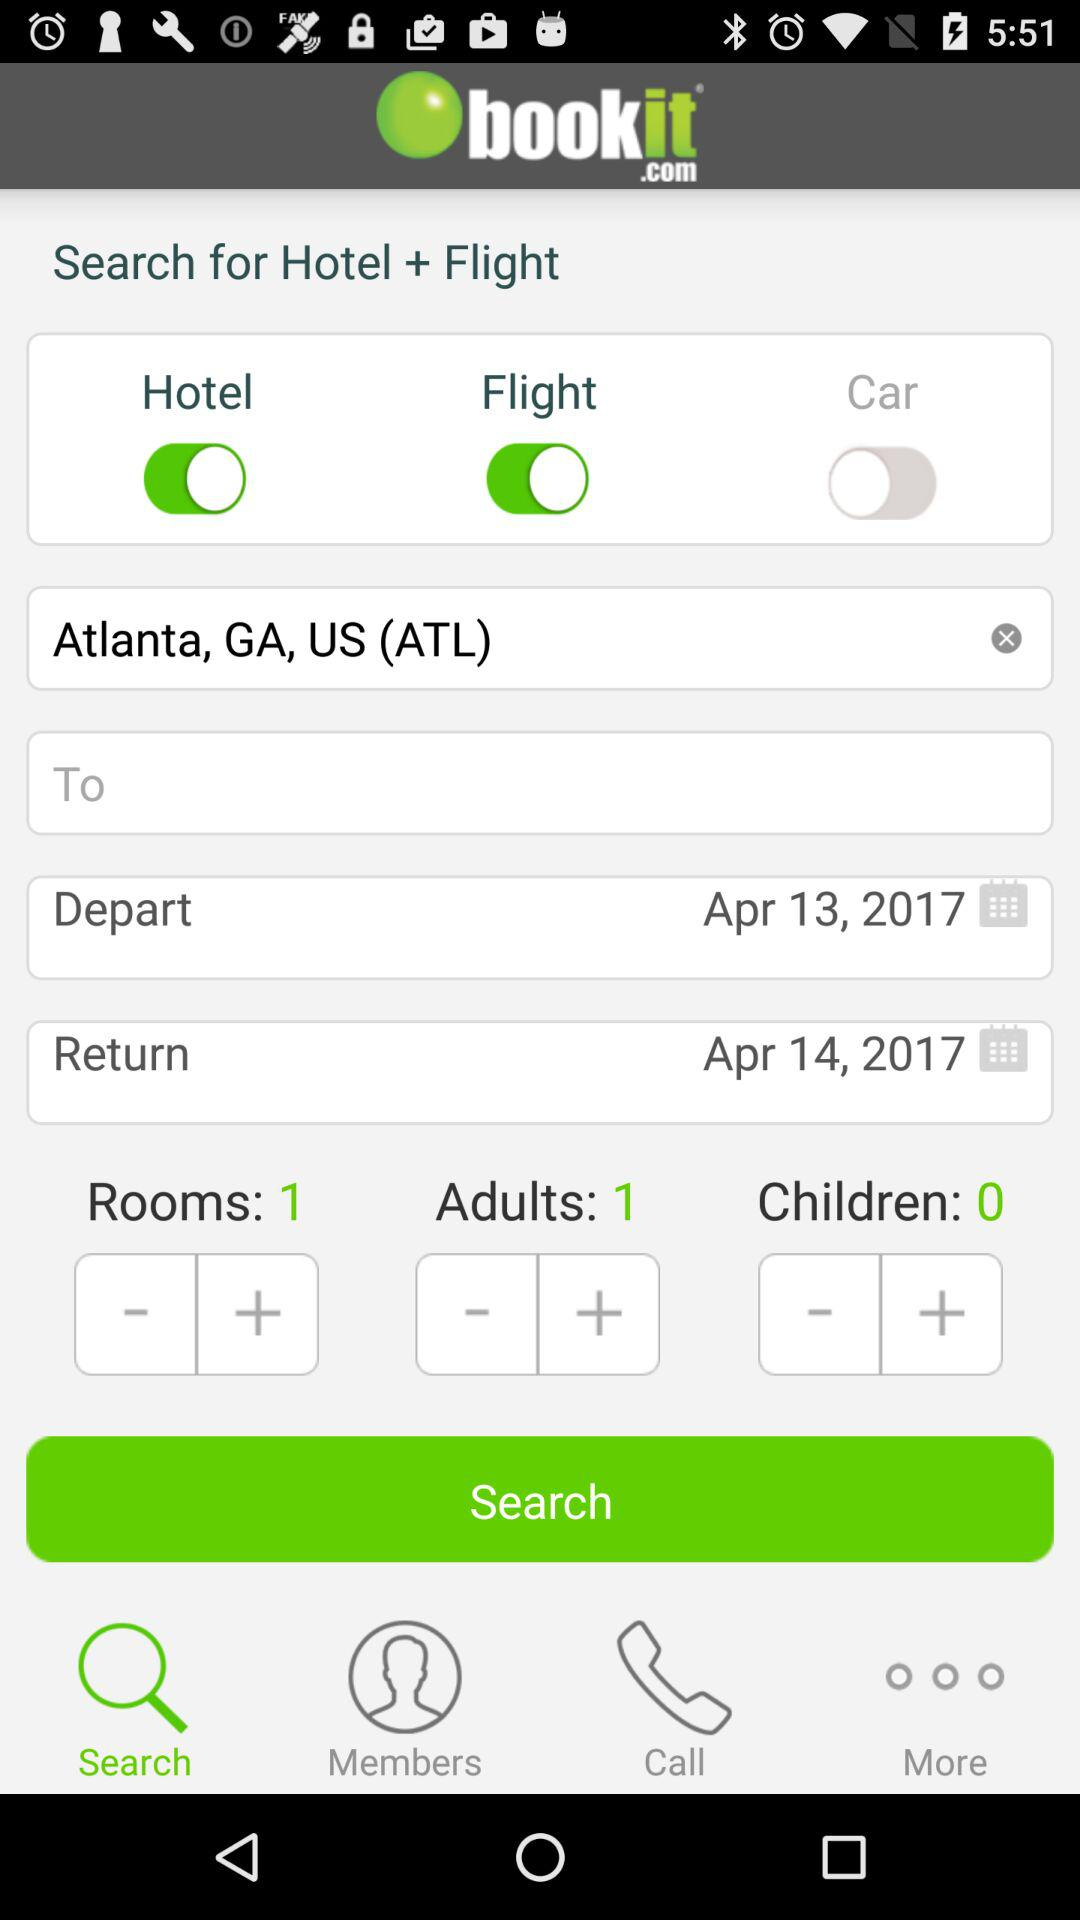What is the status of the "Flight"? The status of the "Flight" is "on". 